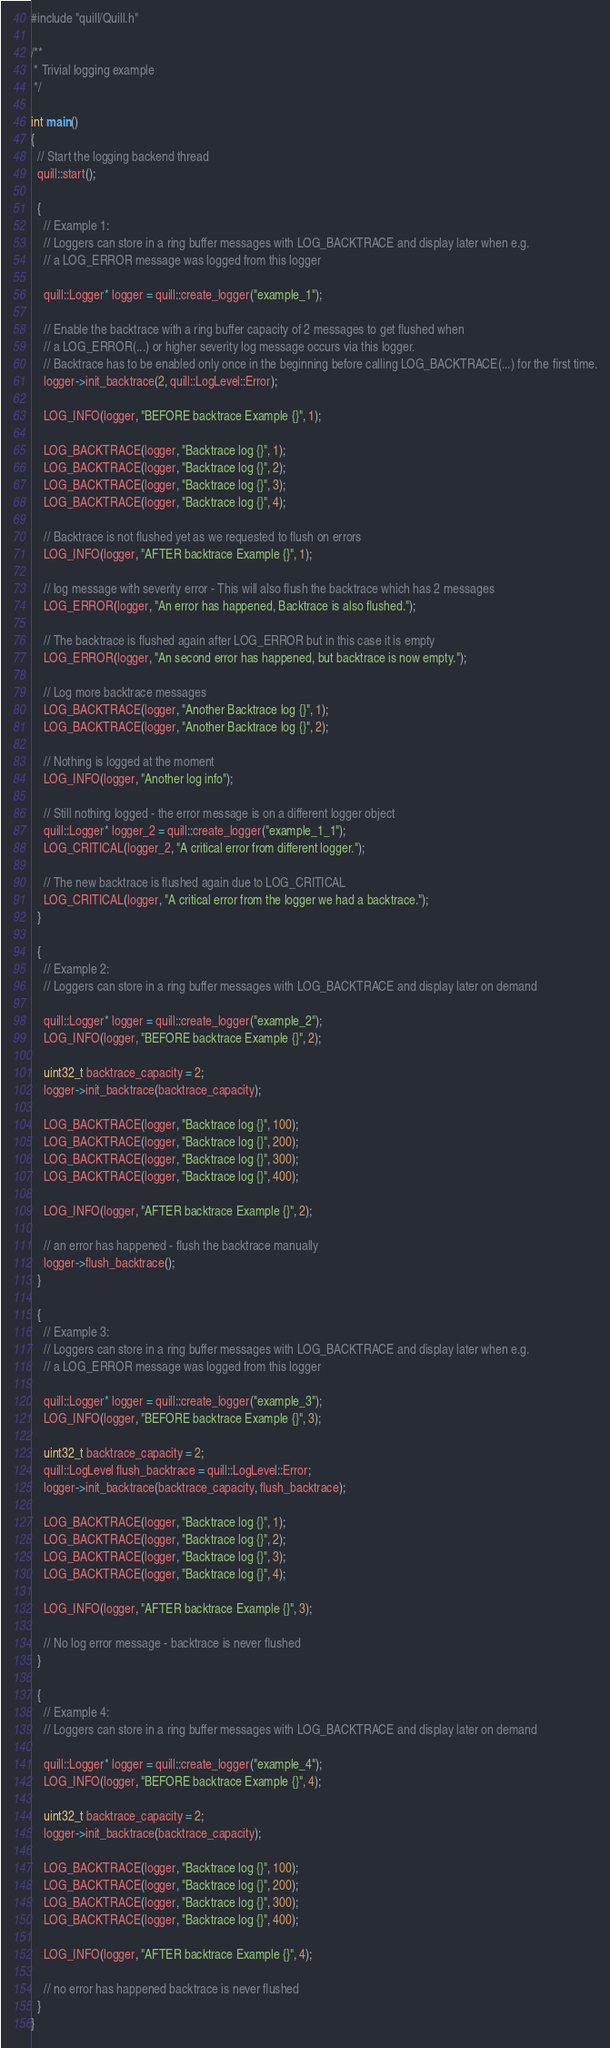<code> <loc_0><loc_0><loc_500><loc_500><_C++_>#include "quill/Quill.h"

/**
 * Trivial logging example
 */

int main()
{
  // Start the logging backend thread
  quill::start();

  {
    // Example 1:
    // Loggers can store in a ring buffer messages with LOG_BACKTRACE and display later when e.g.
    // a LOG_ERROR message was logged from this logger

    quill::Logger* logger = quill::create_logger("example_1");

    // Enable the backtrace with a ring buffer capacity of 2 messages to get flushed when
    // a LOG_ERROR(...) or higher severity log message occurs via this logger.
    // Backtrace has to be enabled only once in the beginning before calling LOG_BACKTRACE(...) for the first time.
    logger->init_backtrace(2, quill::LogLevel::Error);

    LOG_INFO(logger, "BEFORE backtrace Example {}", 1);

    LOG_BACKTRACE(logger, "Backtrace log {}", 1);
    LOG_BACKTRACE(logger, "Backtrace log {}", 2);
    LOG_BACKTRACE(logger, "Backtrace log {}", 3);
    LOG_BACKTRACE(logger, "Backtrace log {}", 4);

    // Backtrace is not flushed yet as we requested to flush on errors
    LOG_INFO(logger, "AFTER backtrace Example {}", 1);

    // log message with severity error - This will also flush the backtrace which has 2 messages
    LOG_ERROR(logger, "An error has happened, Backtrace is also flushed.");

    // The backtrace is flushed again after LOG_ERROR but in this case it is empty
    LOG_ERROR(logger, "An second error has happened, but backtrace is now empty.");

    // Log more backtrace messages
    LOG_BACKTRACE(logger, "Another Backtrace log {}", 1);
    LOG_BACKTRACE(logger, "Another Backtrace log {}", 2);

    // Nothing is logged at the moment
    LOG_INFO(logger, "Another log info");

    // Still nothing logged - the error message is on a different logger object
    quill::Logger* logger_2 = quill::create_logger("example_1_1");
    LOG_CRITICAL(logger_2, "A critical error from different logger.");

    // The new backtrace is flushed again due to LOG_CRITICAL
    LOG_CRITICAL(logger, "A critical error from the logger we had a backtrace.");
  }

  {
    // Example 2:
    // Loggers can store in a ring buffer messages with LOG_BACKTRACE and display later on demand

    quill::Logger* logger = quill::create_logger("example_2");
    LOG_INFO(logger, "BEFORE backtrace Example {}", 2);

    uint32_t backtrace_capacity = 2;
    logger->init_backtrace(backtrace_capacity);

    LOG_BACKTRACE(logger, "Backtrace log {}", 100);
    LOG_BACKTRACE(logger, "Backtrace log {}", 200);
    LOG_BACKTRACE(logger, "Backtrace log {}", 300);
    LOG_BACKTRACE(logger, "Backtrace log {}", 400);

    LOG_INFO(logger, "AFTER backtrace Example {}", 2);

    // an error has happened - flush the backtrace manually
    logger->flush_backtrace();
  }

  {
    // Example 3:
    // Loggers can store in a ring buffer messages with LOG_BACKTRACE and display later when e.g.
    // a LOG_ERROR message was logged from this logger

    quill::Logger* logger = quill::create_logger("example_3");
    LOG_INFO(logger, "BEFORE backtrace Example {}", 3);

    uint32_t backtrace_capacity = 2;
    quill::LogLevel flush_backtrace = quill::LogLevel::Error;
    logger->init_backtrace(backtrace_capacity, flush_backtrace);

    LOG_BACKTRACE(logger, "Backtrace log {}", 1);
    LOG_BACKTRACE(logger, "Backtrace log {}", 2);
    LOG_BACKTRACE(logger, "Backtrace log {}", 3);
    LOG_BACKTRACE(logger, "Backtrace log {}", 4);

    LOG_INFO(logger, "AFTER backtrace Example {}", 3);

    // No log error message - backtrace is never flushed
  }

  {
    // Example 4:
    // Loggers can store in a ring buffer messages with LOG_BACKTRACE and display later on demand

    quill::Logger* logger = quill::create_logger("example_4");
    LOG_INFO(logger, "BEFORE backtrace Example {}", 4);

    uint32_t backtrace_capacity = 2;
    logger->init_backtrace(backtrace_capacity);

    LOG_BACKTRACE(logger, "Backtrace log {}", 100);
    LOG_BACKTRACE(logger, "Backtrace log {}", 200);
    LOG_BACKTRACE(logger, "Backtrace log {}", 300);
    LOG_BACKTRACE(logger, "Backtrace log {}", 400);

    LOG_INFO(logger, "AFTER backtrace Example {}", 4);

    // no error has happened backtrace is never flushed
  }
}</code> 